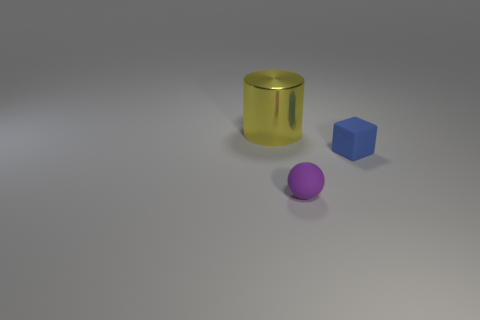Add 2 cyan metal balls. How many objects exist? 5 Subtract all cylinders. How many objects are left? 2 Subtract 0 cyan cylinders. How many objects are left? 3 Subtract all small brown matte cylinders. Subtract all metallic cylinders. How many objects are left? 2 Add 1 yellow cylinders. How many yellow cylinders are left? 2 Add 3 matte spheres. How many matte spheres exist? 4 